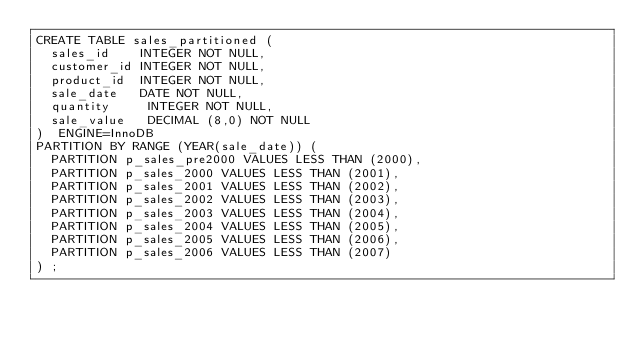Convert code to text. <code><loc_0><loc_0><loc_500><loc_500><_SQL_>CREATE TABLE sales_partitioned (
  sales_id    INTEGER NOT NULL,
  customer_id INTEGER NOT NULL,
  product_id  INTEGER NOT NULL,
  sale_date   DATE NOT NULL,
  quantity     INTEGER NOT NULL,
  sale_value   DECIMAL (8,0) NOT NULL
)  ENGINE=InnoDB
PARTITION BY RANGE (YEAR(sale_date)) (
  PARTITION p_sales_pre2000 VALUES LESS THAN (2000),
  PARTITION p_sales_2000 VALUES LESS THAN (2001),
  PARTITION p_sales_2001 VALUES LESS THAN (2002),
  PARTITION p_sales_2002 VALUES LESS THAN (2003),
  PARTITION p_sales_2003 VALUES LESS THAN (2004),
  PARTITION p_sales_2004 VALUES LESS THAN (2005),
  PARTITION p_sales_2005 VALUES LESS THAN (2006),
  PARTITION p_sales_2006 VALUES LESS THAN (2007)
) ;
</code> 